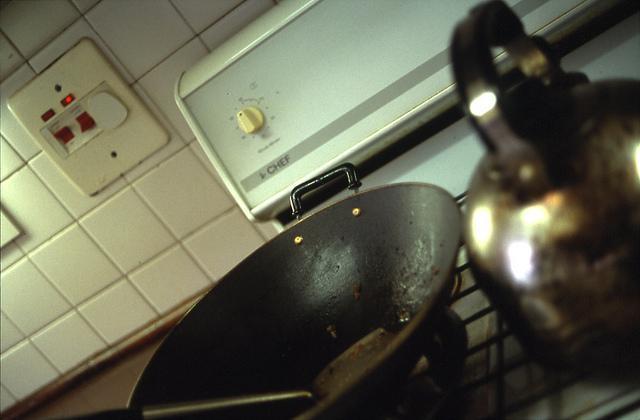How many cars are in between the buses?
Give a very brief answer. 0. 